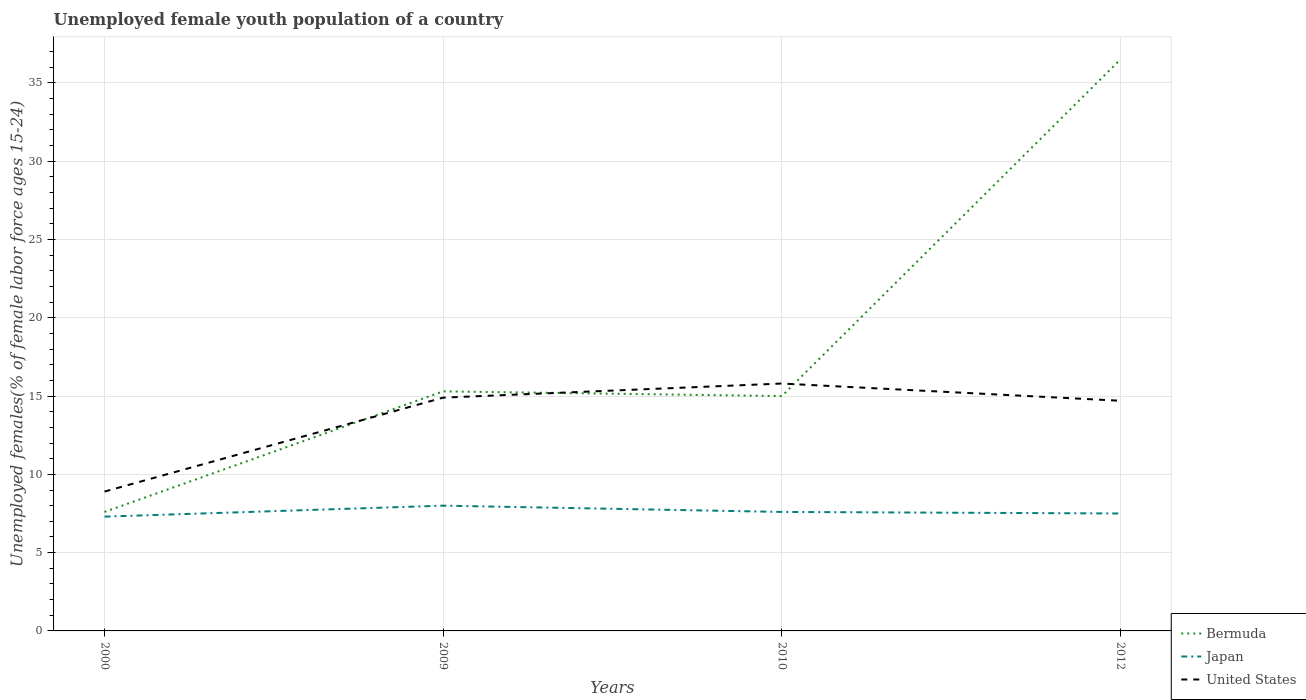How many different coloured lines are there?
Make the answer very short. 3. Does the line corresponding to Japan intersect with the line corresponding to Bermuda?
Give a very brief answer. No. Is the number of lines equal to the number of legend labels?
Offer a terse response. Yes. Across all years, what is the maximum percentage of unemployed female youth population in Bermuda?
Make the answer very short. 7.6. In which year was the percentage of unemployed female youth population in Bermuda maximum?
Provide a short and direct response. 2000. What is the total percentage of unemployed female youth population in Bermuda in the graph?
Keep it short and to the point. -28.9. What is the difference between the highest and the second highest percentage of unemployed female youth population in Bermuda?
Keep it short and to the point. 28.9. How many years are there in the graph?
Your response must be concise. 4. Are the values on the major ticks of Y-axis written in scientific E-notation?
Give a very brief answer. No. Does the graph contain grids?
Ensure brevity in your answer.  Yes. Where does the legend appear in the graph?
Keep it short and to the point. Bottom right. What is the title of the graph?
Your answer should be very brief. Unemployed female youth population of a country. What is the label or title of the X-axis?
Your answer should be very brief. Years. What is the label or title of the Y-axis?
Offer a very short reply. Unemployed females(% of female labor force ages 15-24). What is the Unemployed females(% of female labor force ages 15-24) of Bermuda in 2000?
Your answer should be very brief. 7.6. What is the Unemployed females(% of female labor force ages 15-24) in Japan in 2000?
Provide a short and direct response. 7.3. What is the Unemployed females(% of female labor force ages 15-24) of United States in 2000?
Offer a very short reply. 8.9. What is the Unemployed females(% of female labor force ages 15-24) of Bermuda in 2009?
Give a very brief answer. 15.3. What is the Unemployed females(% of female labor force ages 15-24) in United States in 2009?
Make the answer very short. 14.9. What is the Unemployed females(% of female labor force ages 15-24) of Bermuda in 2010?
Your response must be concise. 15. What is the Unemployed females(% of female labor force ages 15-24) of Japan in 2010?
Keep it short and to the point. 7.6. What is the Unemployed females(% of female labor force ages 15-24) in United States in 2010?
Provide a succinct answer. 15.8. What is the Unemployed females(% of female labor force ages 15-24) of Bermuda in 2012?
Make the answer very short. 36.5. What is the Unemployed females(% of female labor force ages 15-24) in Japan in 2012?
Give a very brief answer. 7.5. What is the Unemployed females(% of female labor force ages 15-24) of United States in 2012?
Your answer should be very brief. 14.7. Across all years, what is the maximum Unemployed females(% of female labor force ages 15-24) of Bermuda?
Provide a short and direct response. 36.5. Across all years, what is the maximum Unemployed females(% of female labor force ages 15-24) in United States?
Provide a short and direct response. 15.8. Across all years, what is the minimum Unemployed females(% of female labor force ages 15-24) in Bermuda?
Provide a succinct answer. 7.6. Across all years, what is the minimum Unemployed females(% of female labor force ages 15-24) of Japan?
Ensure brevity in your answer.  7.3. Across all years, what is the minimum Unemployed females(% of female labor force ages 15-24) of United States?
Your answer should be compact. 8.9. What is the total Unemployed females(% of female labor force ages 15-24) of Bermuda in the graph?
Ensure brevity in your answer.  74.4. What is the total Unemployed females(% of female labor force ages 15-24) in Japan in the graph?
Give a very brief answer. 30.4. What is the total Unemployed females(% of female labor force ages 15-24) of United States in the graph?
Ensure brevity in your answer.  54.3. What is the difference between the Unemployed females(% of female labor force ages 15-24) in Japan in 2000 and that in 2009?
Your answer should be compact. -0.7. What is the difference between the Unemployed females(% of female labor force ages 15-24) in Japan in 2000 and that in 2010?
Offer a terse response. -0.3. What is the difference between the Unemployed females(% of female labor force ages 15-24) in Bermuda in 2000 and that in 2012?
Your answer should be very brief. -28.9. What is the difference between the Unemployed females(% of female labor force ages 15-24) in Japan in 2000 and that in 2012?
Your answer should be compact. -0.2. What is the difference between the Unemployed females(% of female labor force ages 15-24) in Bermuda in 2009 and that in 2010?
Keep it short and to the point. 0.3. What is the difference between the Unemployed females(% of female labor force ages 15-24) in United States in 2009 and that in 2010?
Your response must be concise. -0.9. What is the difference between the Unemployed females(% of female labor force ages 15-24) in Bermuda in 2009 and that in 2012?
Your answer should be compact. -21.2. What is the difference between the Unemployed females(% of female labor force ages 15-24) in Japan in 2009 and that in 2012?
Keep it short and to the point. 0.5. What is the difference between the Unemployed females(% of female labor force ages 15-24) in United States in 2009 and that in 2012?
Ensure brevity in your answer.  0.2. What is the difference between the Unemployed females(% of female labor force ages 15-24) in Bermuda in 2010 and that in 2012?
Offer a very short reply. -21.5. What is the difference between the Unemployed females(% of female labor force ages 15-24) of Japan in 2010 and that in 2012?
Provide a short and direct response. 0.1. What is the difference between the Unemployed females(% of female labor force ages 15-24) in United States in 2010 and that in 2012?
Your response must be concise. 1.1. What is the difference between the Unemployed females(% of female labor force ages 15-24) of Bermuda in 2000 and the Unemployed females(% of female labor force ages 15-24) of United States in 2009?
Your answer should be compact. -7.3. What is the difference between the Unemployed females(% of female labor force ages 15-24) in Bermuda in 2000 and the Unemployed females(% of female labor force ages 15-24) in United States in 2010?
Your answer should be compact. -8.2. What is the difference between the Unemployed females(% of female labor force ages 15-24) in Bermuda in 2000 and the Unemployed females(% of female labor force ages 15-24) in Japan in 2012?
Ensure brevity in your answer.  0.1. What is the difference between the Unemployed females(% of female labor force ages 15-24) of Bermuda in 2000 and the Unemployed females(% of female labor force ages 15-24) of United States in 2012?
Give a very brief answer. -7.1. What is the difference between the Unemployed females(% of female labor force ages 15-24) of Bermuda in 2009 and the Unemployed females(% of female labor force ages 15-24) of Japan in 2010?
Offer a terse response. 7.7. What is the difference between the Unemployed females(% of female labor force ages 15-24) in Japan in 2009 and the Unemployed females(% of female labor force ages 15-24) in United States in 2010?
Give a very brief answer. -7.8. What is the difference between the Unemployed females(% of female labor force ages 15-24) of Bermuda in 2009 and the Unemployed females(% of female labor force ages 15-24) of United States in 2012?
Your response must be concise. 0.6. What is the difference between the Unemployed females(% of female labor force ages 15-24) of Bermuda in 2010 and the Unemployed females(% of female labor force ages 15-24) of Japan in 2012?
Ensure brevity in your answer.  7.5. What is the difference between the Unemployed females(% of female labor force ages 15-24) in Bermuda in 2010 and the Unemployed females(% of female labor force ages 15-24) in United States in 2012?
Make the answer very short. 0.3. What is the average Unemployed females(% of female labor force ages 15-24) of Japan per year?
Make the answer very short. 7.6. What is the average Unemployed females(% of female labor force ages 15-24) in United States per year?
Offer a terse response. 13.57. In the year 2000, what is the difference between the Unemployed females(% of female labor force ages 15-24) in Bermuda and Unemployed females(% of female labor force ages 15-24) in Japan?
Keep it short and to the point. 0.3. In the year 2009, what is the difference between the Unemployed females(% of female labor force ages 15-24) of Bermuda and Unemployed females(% of female labor force ages 15-24) of Japan?
Ensure brevity in your answer.  7.3. In the year 2009, what is the difference between the Unemployed females(% of female labor force ages 15-24) of Bermuda and Unemployed females(% of female labor force ages 15-24) of United States?
Provide a short and direct response. 0.4. In the year 2010, what is the difference between the Unemployed females(% of female labor force ages 15-24) in Bermuda and Unemployed females(% of female labor force ages 15-24) in United States?
Give a very brief answer. -0.8. In the year 2010, what is the difference between the Unemployed females(% of female labor force ages 15-24) of Japan and Unemployed females(% of female labor force ages 15-24) of United States?
Offer a terse response. -8.2. In the year 2012, what is the difference between the Unemployed females(% of female labor force ages 15-24) of Bermuda and Unemployed females(% of female labor force ages 15-24) of United States?
Make the answer very short. 21.8. What is the ratio of the Unemployed females(% of female labor force ages 15-24) of Bermuda in 2000 to that in 2009?
Keep it short and to the point. 0.5. What is the ratio of the Unemployed females(% of female labor force ages 15-24) in Japan in 2000 to that in 2009?
Provide a succinct answer. 0.91. What is the ratio of the Unemployed females(% of female labor force ages 15-24) in United States in 2000 to that in 2009?
Give a very brief answer. 0.6. What is the ratio of the Unemployed females(% of female labor force ages 15-24) of Bermuda in 2000 to that in 2010?
Provide a succinct answer. 0.51. What is the ratio of the Unemployed females(% of female labor force ages 15-24) in Japan in 2000 to that in 2010?
Ensure brevity in your answer.  0.96. What is the ratio of the Unemployed females(% of female labor force ages 15-24) of United States in 2000 to that in 2010?
Provide a short and direct response. 0.56. What is the ratio of the Unemployed females(% of female labor force ages 15-24) in Bermuda in 2000 to that in 2012?
Make the answer very short. 0.21. What is the ratio of the Unemployed females(% of female labor force ages 15-24) of Japan in 2000 to that in 2012?
Offer a very short reply. 0.97. What is the ratio of the Unemployed females(% of female labor force ages 15-24) of United States in 2000 to that in 2012?
Offer a very short reply. 0.61. What is the ratio of the Unemployed females(% of female labor force ages 15-24) in Japan in 2009 to that in 2010?
Your response must be concise. 1.05. What is the ratio of the Unemployed females(% of female labor force ages 15-24) in United States in 2009 to that in 2010?
Offer a terse response. 0.94. What is the ratio of the Unemployed females(% of female labor force ages 15-24) of Bermuda in 2009 to that in 2012?
Give a very brief answer. 0.42. What is the ratio of the Unemployed females(% of female labor force ages 15-24) in Japan in 2009 to that in 2012?
Provide a succinct answer. 1.07. What is the ratio of the Unemployed females(% of female labor force ages 15-24) of United States in 2009 to that in 2012?
Your answer should be compact. 1.01. What is the ratio of the Unemployed females(% of female labor force ages 15-24) of Bermuda in 2010 to that in 2012?
Make the answer very short. 0.41. What is the ratio of the Unemployed females(% of female labor force ages 15-24) of Japan in 2010 to that in 2012?
Give a very brief answer. 1.01. What is the ratio of the Unemployed females(% of female labor force ages 15-24) in United States in 2010 to that in 2012?
Your response must be concise. 1.07. What is the difference between the highest and the second highest Unemployed females(% of female labor force ages 15-24) of Bermuda?
Keep it short and to the point. 21.2. What is the difference between the highest and the second highest Unemployed females(% of female labor force ages 15-24) of Japan?
Offer a very short reply. 0.4. What is the difference between the highest and the second highest Unemployed females(% of female labor force ages 15-24) of United States?
Offer a very short reply. 0.9. What is the difference between the highest and the lowest Unemployed females(% of female labor force ages 15-24) of Bermuda?
Your answer should be very brief. 28.9. 